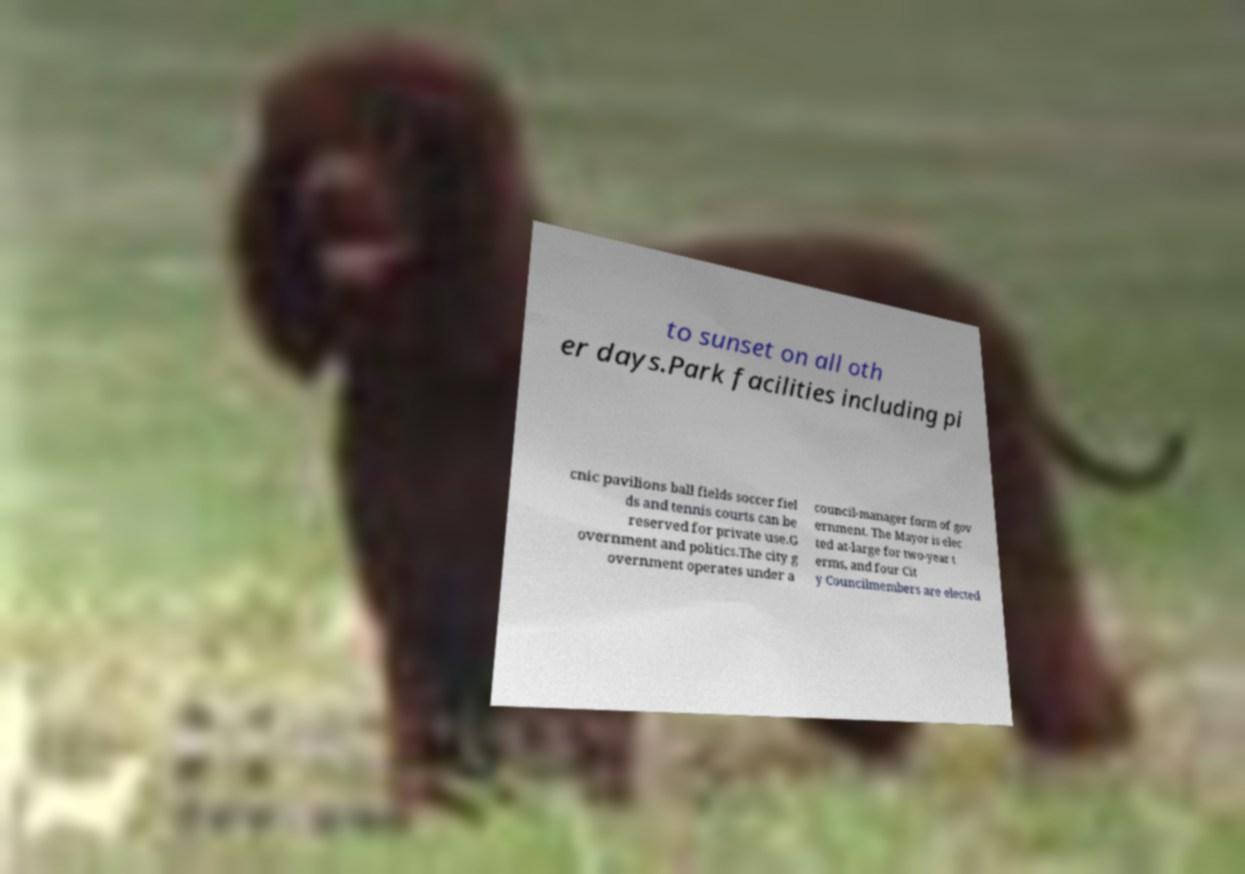For documentation purposes, I need the text within this image transcribed. Could you provide that? to sunset on all oth er days.Park facilities including pi cnic pavilions ball fields soccer fiel ds and tennis courts can be reserved for private use.G overnment and politics.The city g overnment operates under a council-manager form of gov ernment. The Mayor is elec ted at-large for two-year t erms, and four Cit y Councilmembers are elected 